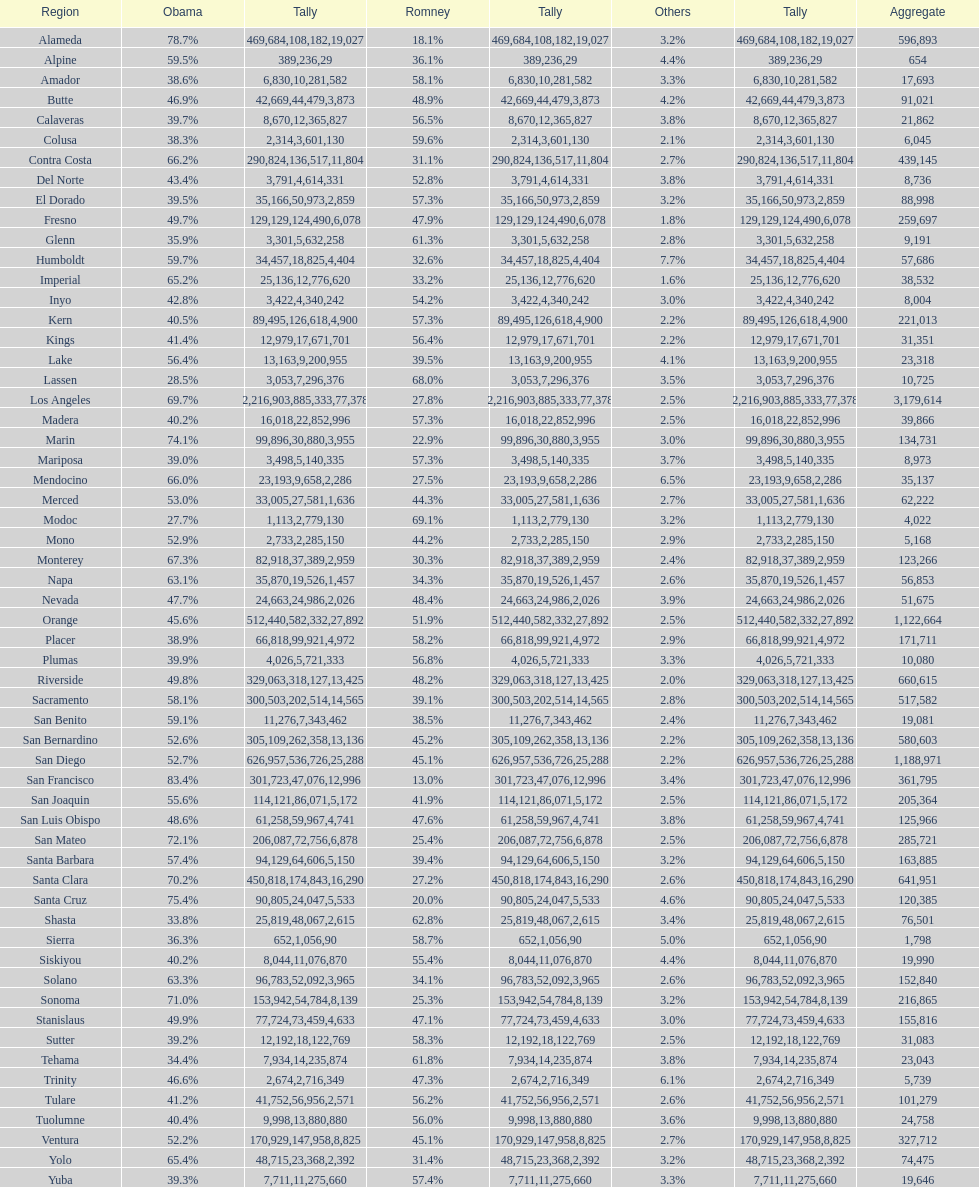How many counties had at least 75% of the votes for obama? 3. 